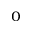Convert formula to latex. <formula><loc_0><loc_0><loc_500><loc_500>_ { 0 }</formula> 